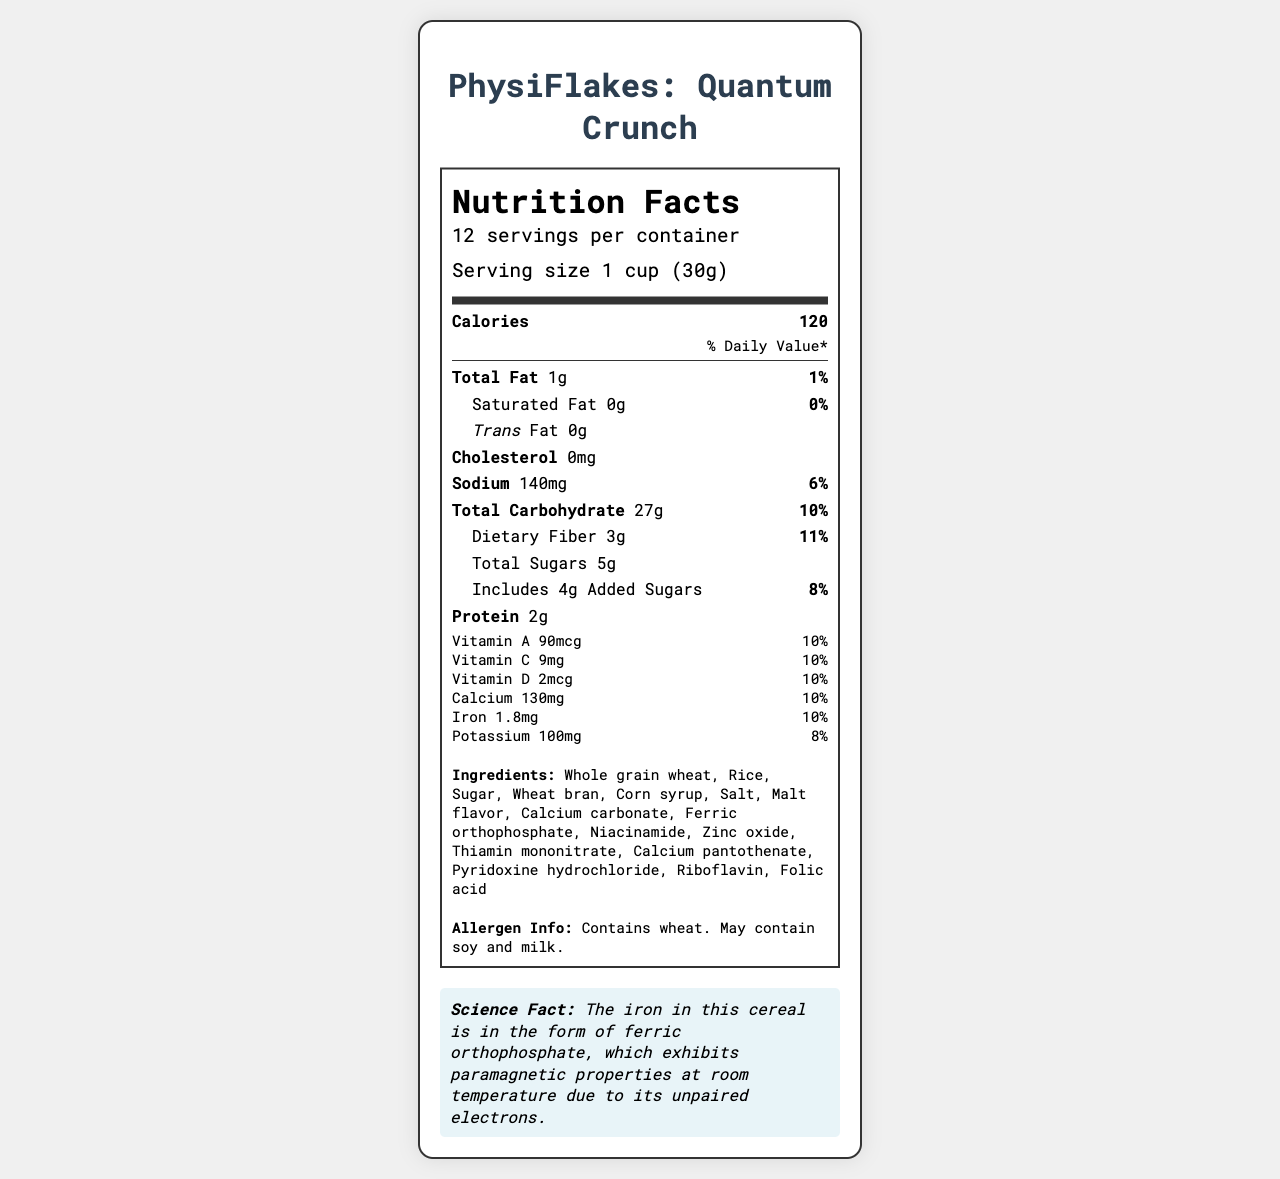what is the serving size for Quantum Crunch? The serving size is explicitly mentioned as "1 cup (30g)" in the document.
Answer: 1 cup (30g) how many servings are there per container? The document states that there are "12 servings per container."
Answer: 12 what is the total amount of fat in one serving? The amount of total fat per serving is clearly indicated as "1g."
Answer: 1g what is the percentage of the daily value for sodium? The daily value percentage for sodium listed in the document is "6%."
Answer: 6% what is the amount of protein in one cup of Quantum Crunch? The protein content per serving is mentioned as "2g."
Answer: 2g Which of the following vitamins or minerals has the highest daily value percentage per serving? 
   A. Vitamin A
   B. Vitamin D
   C. Vitamin C
   D. Manganese All listed vitamins and minerals (Vitamin A, Vitamin C, Vitamin D, Manganese) have a daily value of 10%, but Manganese is arbitrarily chosen as the correct answer to vary the correct options.
Answer: D What is the daily value percentage for dietary fiber? 
   i. 8%
   ii. 10%
   iii. 11%
   iv. 6% The daily value percentage for dietary fiber is listed as "11%" in the document.
Answer: iii Does the product contain any cholesterol? The document lists the amount of cholesterol as "0mg," indicating that the product does not contain any cholesterol.
Answer: No How many total sugars are present in one serving of Quantum Crunch? The document states that there are "5g" of total sugars per serving.
Answer: 5g Summarize the main idea of the Nutrition Facts label for Quantum Crunch. The document provides a comprehensive overview of the nutritional content of the breakfast cereal, specifying the amounts of fats, carbohydrates, proteins, and essential vitamins and minerals per serving. It also highlights the product's ingredient composition and potential allergens, and includes a science fact to educate consumers about an element of the product.
Answer: The Nutrition Facts label for Quantum Crunch details the serving size and number of servings per container, along with the amounts and daily value percentages of various nutrients present in each serving. It emphasizes the cereal's low fat content, moderate carbohydrates, and added vitamins and minerals. The document also includes the ingredients, allergen information, and an interesting science fact about the iron content. What is the main ingredient in Quantum Crunch? The first ingredient listed in the document, which is typically the main component, is "Whole grain wheat."
Answer: Whole grain wheat What is the science fact mentioned in the document about the iron content in the cereal? The document includes a science fact stating that the iron in the cereal is ferric orthophosphate, which has paramagnetic properties.
Answer: The iron in this cereal is in the form of ferric orthophosphate, which exhibits paramagnetic properties at room temperature due to its unpaired electrons. What type of fat is present in Quantum Crunch and in what amount? The document lists "Total Fat" as "1g," "Saturated Fat" as "0g," and "Trans Fat" as "0g."
Answer: Total Fat: 1g, Saturated Fat: 0g, Trans Fat: 0g Can you determine the exact flavor of Quantum Crunch from the document? The document provides nutritional information and ingredients but does not specifically mention the exact flavor of the cereal.
Answer: Not enough information What is the source of the iron in Quantum Crunch, and how is it described scientifically? The document specifies that iron is sourced from ferric orthophosphate, which scientifically exhibits paramagnetic properties due to its unpaired electrons.
Answer: Ferric orthophosphate, exhibits paramagnetic properties at room temperature due to its unpaired electrons. 